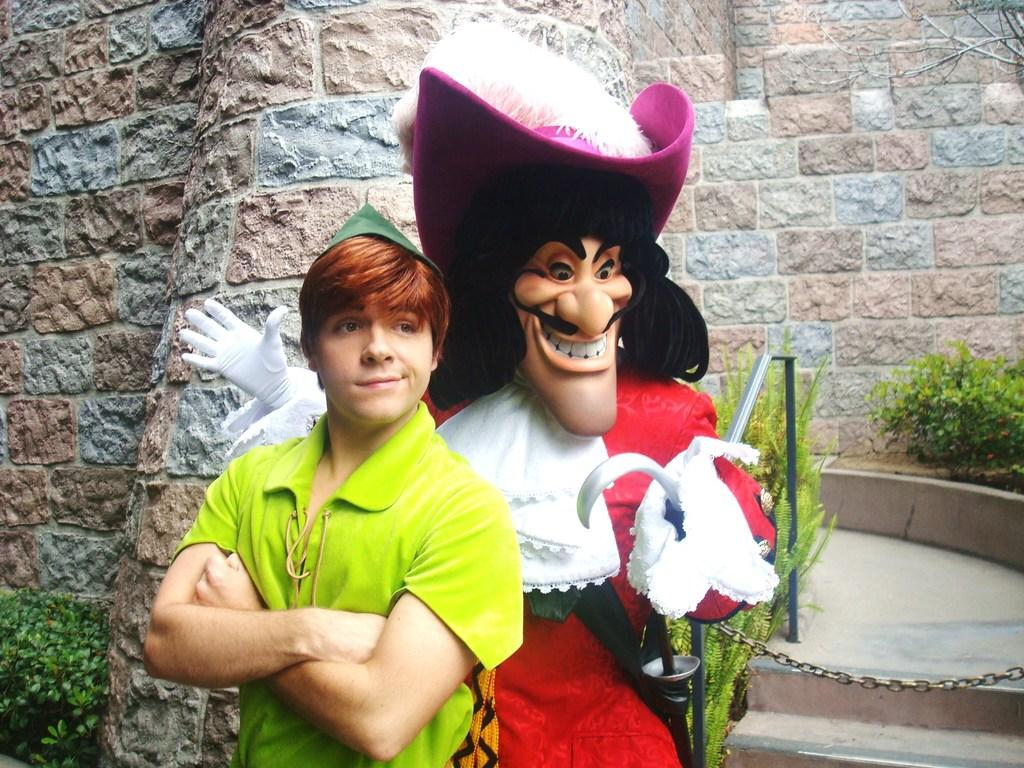Who is present in the image? There is a man in the image. What is the man standing beside? The man is standing beside a cartoon statue. What is the man wearing? The man is wearing a green color t-shirt. What can be seen in the background of the image? There is a wall and plants in the background of the image. What type of crow can be seen perched on the cartoon statue in the image? There is no crow present in the image; the man is standing beside a cartoon statue. How many cattle are visible in the image? There are no cattle present in the image. 